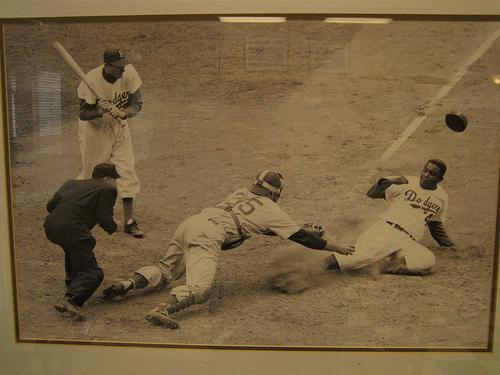Mention the predominant colors seen in the image and the focus of the camera. The image captures hues of white, black, and green clothing on the players and surroundings, highlighting the intense action between the sliding player and the catcher. Write a short caption summarizing the main events in the image. Baseball player slides to base as catcher jumps forward to tag him in an intense game. Write a news headline for the image depicting the main event. Intense Baseball Game: Player Slides to Base as Catcher Leaps for Tag in Thrilling Match! Write a single sentence that captures the main emotion and excitement of the scene in the image. The air is electrified as the player slides fiercely to the base, while the catcher makes a dramatic leap for the game-defining tag. Imagine you are a painter, describe the main composition of this painting and the actions of the characters. At the heart of the canvas, two figures locked in a dynamic dance: a triumphant player sliding towards home plate, while a desperate catcher leaps into the climax, umpire silently observing them both. Provide a brief overview of the primary action taking place in the image. A baseball player is sliding onto the base while the catcher jumps forward to tag him, with both wearing their respective team uniforms. Use poetic language to describe the main action happening in the image. Amidst the dusty field, a valiant player slides swiftly towards his goal, as the vigilant catcher leaps to seize victory from his grasp. List the primary objects and people involved in the scene from the image. Man holding baseball bat, player sliding onto base, catcher jumping forward, umpire in a black suit. Give a brief description of the attire of the main subjects in the image. The players are wearing baseball uniforms, one in white sliding to the base and the other a catcher in a distinct uniform; the umpire is dressed in all black. 